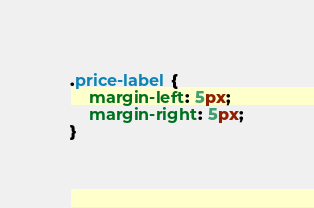<code> <loc_0><loc_0><loc_500><loc_500><_CSS_>
.price-label {
    margin-left: 5px;
    margin-right: 5px;
}

</code> 